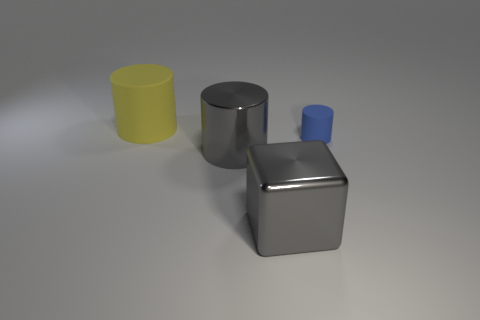Are there any other things that have the same size as the blue matte cylinder?
Make the answer very short. No. What number of cylinders are big gray objects or tiny blue objects?
Provide a short and direct response. 2. There is a thing that is the same material as the big gray cylinder; what is its color?
Offer a terse response. Gray. Does the small blue cylinder have the same material as the large thing behind the blue matte cylinder?
Your answer should be compact. Yes. How many objects are gray objects or shiny cylinders?
Ensure brevity in your answer.  2. There is a cylinder that is the same color as the big cube; what material is it?
Offer a terse response. Metal. Are there any big yellow objects that have the same shape as the small object?
Your answer should be compact. Yes. There is a small rubber cylinder; how many big metallic things are on the right side of it?
Keep it short and to the point. 0. There is a object behind the matte object to the right of the yellow object; what is its material?
Make the answer very short. Rubber. There is a gray cylinder that is the same size as the yellow rubber object; what is its material?
Offer a very short reply. Metal. 